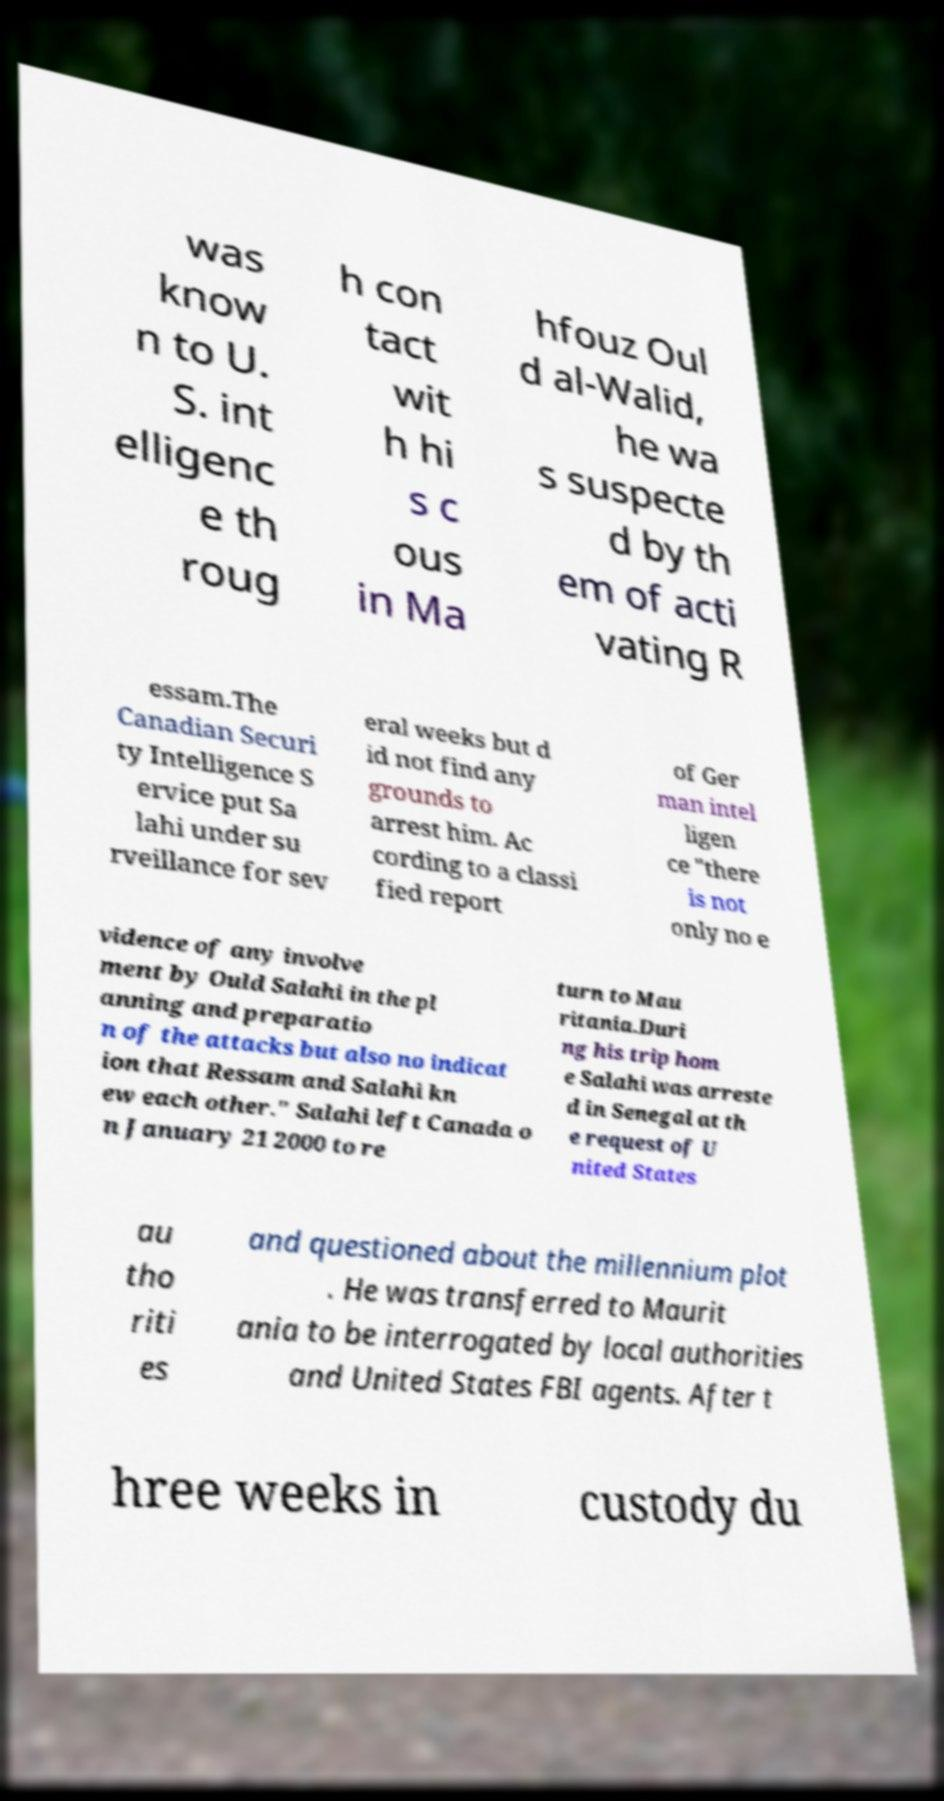What messages or text are displayed in this image? I need them in a readable, typed format. was know n to U. S. int elligenc e th roug h con tact wit h hi s c ous in Ma hfouz Oul d al-Walid, he wa s suspecte d by th em of acti vating R essam.The Canadian Securi ty Intelligence S ervice put Sa lahi under su rveillance for sev eral weeks but d id not find any grounds to arrest him. Ac cording to a classi fied report of Ger man intel ligen ce "there is not only no e vidence of any involve ment by Ould Salahi in the pl anning and preparatio n of the attacks but also no indicat ion that Ressam and Salahi kn ew each other." Salahi left Canada o n January 21 2000 to re turn to Mau ritania.Duri ng his trip hom e Salahi was arreste d in Senegal at th e request of U nited States au tho riti es and questioned about the millennium plot . He was transferred to Maurit ania to be interrogated by local authorities and United States FBI agents. After t hree weeks in custody du 